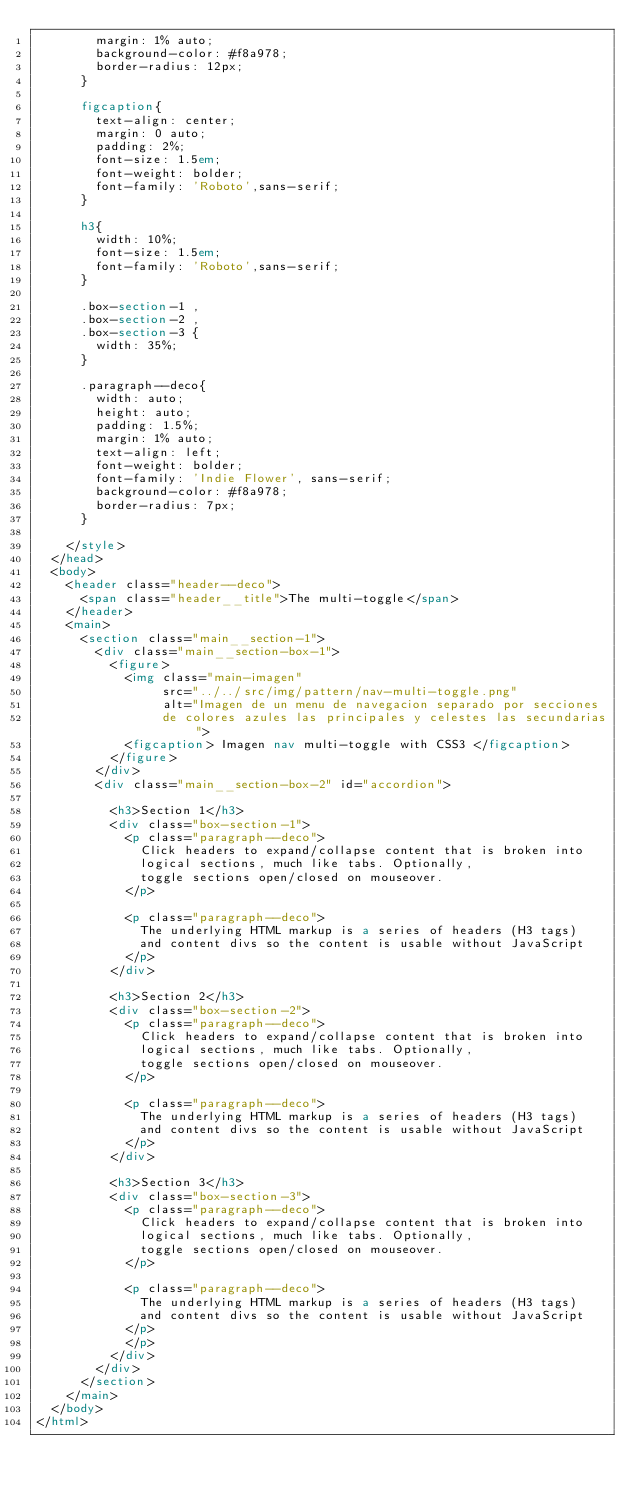Convert code to text. <code><loc_0><loc_0><loc_500><loc_500><_HTML_>        margin: 1% auto;
        background-color: #f8a978;
        border-radius: 12px;
      }

      figcaption{
        text-align: center;
        margin: 0 auto;
        padding: 2%;
        font-size: 1.5em;
        font-weight: bolder;
        font-family: 'Roboto',sans-serif;
      }

      h3{
        width: 10%;
        font-size: 1.5em;
        font-family: 'Roboto',sans-serif;
      }

      .box-section-1 , 
      .box-section-2 , 
      .box-section-3 {
        width: 35%;
      }

      .paragraph--deco{
        width: auto;
        height: auto;
        padding: 1.5%;
        margin: 1% auto;
        text-align: left;
        font-weight: bolder;
        font-family: 'Indie Flower', sans-serif;
        background-color: #f8a978;
        border-radius: 7px;
      }

    </style>
  </head>
  <body>
    <header class="header--deco">
      <span class="header__title">The multi-toggle</span>
    </header>
    <main>
      <section class="main__section-1">
        <div class="main__section-box-1">
          <figure>
            <img class="main-imagen" 
                 src="../../src/img/pattern/nav-multi-toggle.png" 
                 alt="Imagen de un menu de navegacion separado por secciones 
                 de colores azules las principales y celestes las secundarias">
            <figcaption> Imagen nav multi-toggle with CSS3 </figcaption>
          </figure>
        </div>
        <div class="main__section-box-2" id="accordion">

          <h3>Section 1</h3>
          <div class="box-section-1">
            <p class="paragraph--deco">
              Click headers to expand/collapse content that is broken into 
              logical sections, much like tabs. Optionally, 
              toggle sections open/closed on mouseover.
            </p>

            <p class="paragraph--deco">
              The underlying HTML markup is a series of headers (H3 tags) 
              and content divs so the content is usable without JavaScript
            </p>
          </div>

          <h3>Section 2</h3>
          <div class="box-section-2">
            <p class="paragraph--deco">
              Click headers to expand/collapse content that is broken into 
              logical sections, much like tabs. Optionally, 
              toggle sections open/closed on mouseover.
            </p>

            <p class="paragraph--deco">
              The underlying HTML markup is a series of headers (H3 tags) 
              and content divs so the content is usable without JavaScript
            </p>
          </div>

          <h3>Section 3</h3>
          <div class="box-section-3">
            <p class="paragraph--deco">
              Click headers to expand/collapse content that is broken into 
              logical sections, much like tabs. Optionally, 
              toggle sections open/closed on mouseover.
            </p>

            <p class="paragraph--deco">
              The underlying HTML markup is a series of headers (H3 tags) 
              and content divs so the content is usable without JavaScript
            </p>
            </p>
          </div>
        </div>
      </section>
    </main>
  </body>
</html>
</code> 